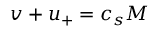Convert formula to latex. <formula><loc_0><loc_0><loc_500><loc_500>v + u _ { + } = c _ { s } M</formula> 